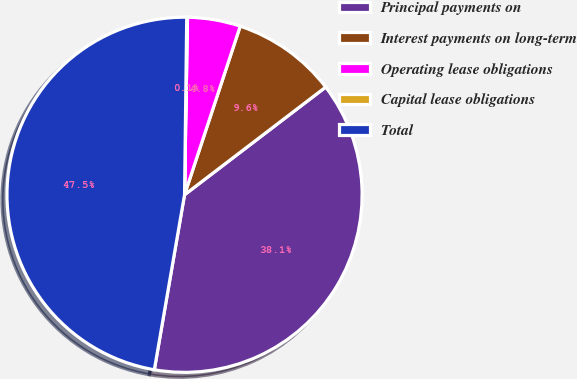Convert chart to OTSL. <chart><loc_0><loc_0><loc_500><loc_500><pie_chart><fcel>Principal payments on<fcel>Interest payments on long-term<fcel>Operating lease obligations<fcel>Capital lease obligations<fcel>Total<nl><fcel>38.09%<fcel>9.55%<fcel>4.81%<fcel>0.07%<fcel>47.47%<nl></chart> 